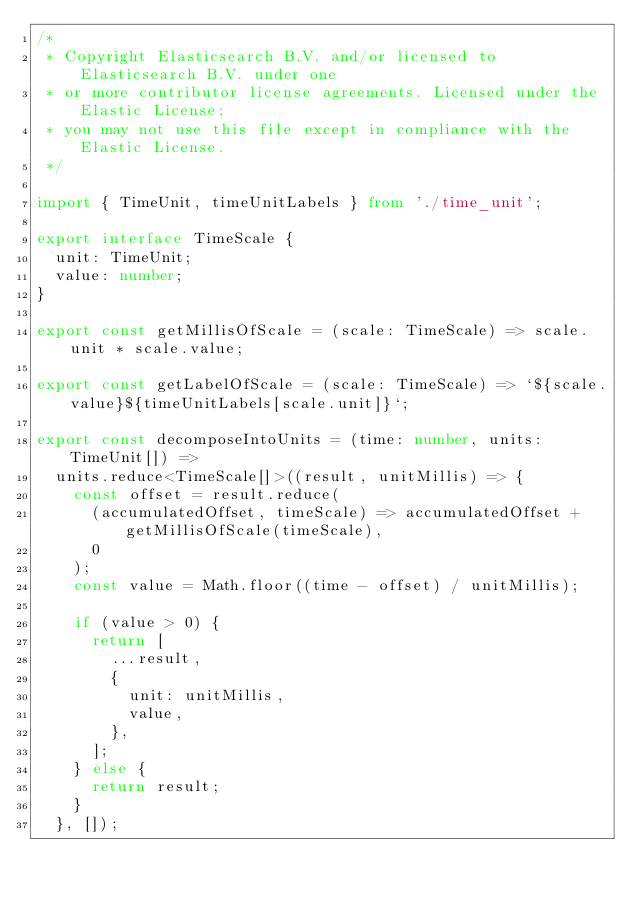Convert code to text. <code><loc_0><loc_0><loc_500><loc_500><_TypeScript_>/*
 * Copyright Elasticsearch B.V. and/or licensed to Elasticsearch B.V. under one
 * or more contributor license agreements. Licensed under the Elastic License;
 * you may not use this file except in compliance with the Elastic License.
 */

import { TimeUnit, timeUnitLabels } from './time_unit';

export interface TimeScale {
  unit: TimeUnit;
  value: number;
}

export const getMillisOfScale = (scale: TimeScale) => scale.unit * scale.value;

export const getLabelOfScale = (scale: TimeScale) => `${scale.value}${timeUnitLabels[scale.unit]}`;

export const decomposeIntoUnits = (time: number, units: TimeUnit[]) =>
  units.reduce<TimeScale[]>((result, unitMillis) => {
    const offset = result.reduce(
      (accumulatedOffset, timeScale) => accumulatedOffset + getMillisOfScale(timeScale),
      0
    );
    const value = Math.floor((time - offset) / unitMillis);

    if (value > 0) {
      return [
        ...result,
        {
          unit: unitMillis,
          value,
        },
      ];
    } else {
      return result;
    }
  }, []);
</code> 